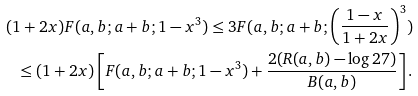Convert formula to latex. <formula><loc_0><loc_0><loc_500><loc_500>( 1 + 2 x ) F ( a , b ; a + b ; 1 - x ^ { 3 } ) \leq 3 F ( a , b ; a + b ; \left ( \frac { 1 - x } { 1 + 2 x } \right ) ^ { 3 } ) \\ \leq ( 1 + 2 x ) \left [ F ( a , b ; a + b ; 1 - x ^ { 3 } ) + \frac { 2 ( R ( a , b ) - \log { 2 7 } ) } { B ( a , b ) } \right ] .</formula> 